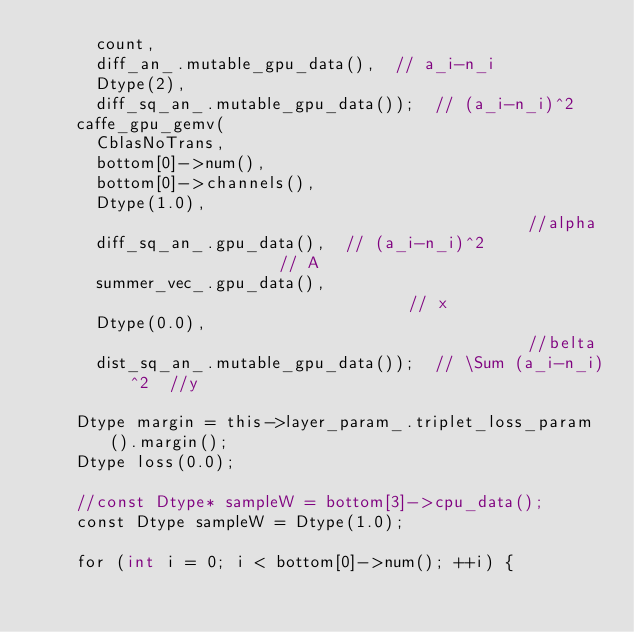<code> <loc_0><loc_0><loc_500><loc_500><_Cuda_>      count,
      diff_an_.mutable_gpu_data(),  // a_i-n_i
      Dtype(2),
      diff_sq_an_.mutable_gpu_data());  // (a_i-n_i)^2
    caffe_gpu_gemv(
      CblasNoTrans,
      bottom[0]->num(),
      bottom[0]->channels(),
      Dtype(1.0),                                         //alpha
      diff_sq_an_.gpu_data(),  // (a_i-n_i)^2                // A
      summer_vec_.gpu_data(),                             // x
      Dtype(0.0),                                         //belta
      dist_sq_an_.mutable_gpu_data());  // \Sum (a_i-n_i)^2  //y

    Dtype margin = this->layer_param_.triplet_loss_param().margin();
    Dtype loss(0.0);

    //const Dtype* sampleW = bottom[3]->cpu_data();
    const Dtype sampleW = Dtype(1.0);

    for (int i = 0; i < bottom[0]->num(); ++i) {</code> 